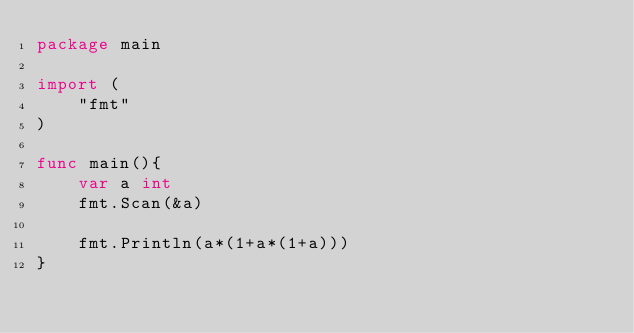Convert code to text. <code><loc_0><loc_0><loc_500><loc_500><_Go_>package main

import (
    "fmt"
)

func main(){
    var a int
    fmt.Scan(&a)

    fmt.Println(a*(1+a*(1+a)))
}
</code> 